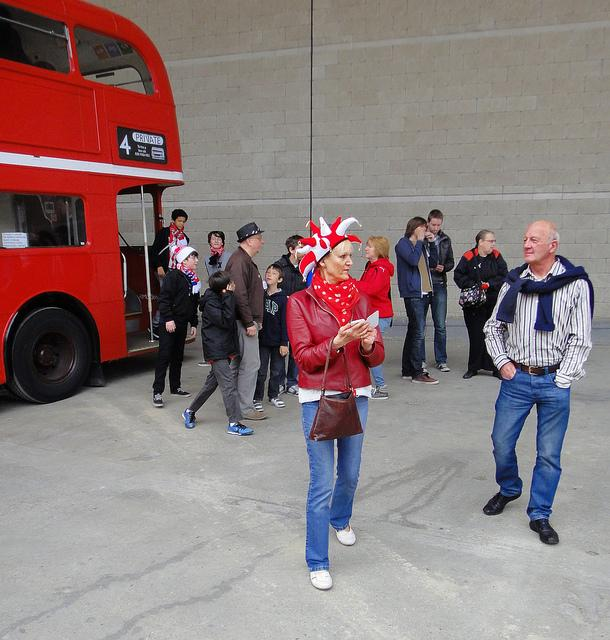What activity do the persons near the bus take part in? Please explain your reasoning. tourism. The persons are near the bus taking part in some tourisms. 